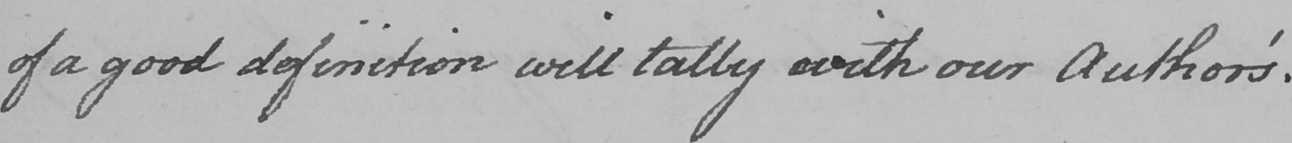Can you read and transcribe this handwriting? of a good definition will tally with our Author ' s . 